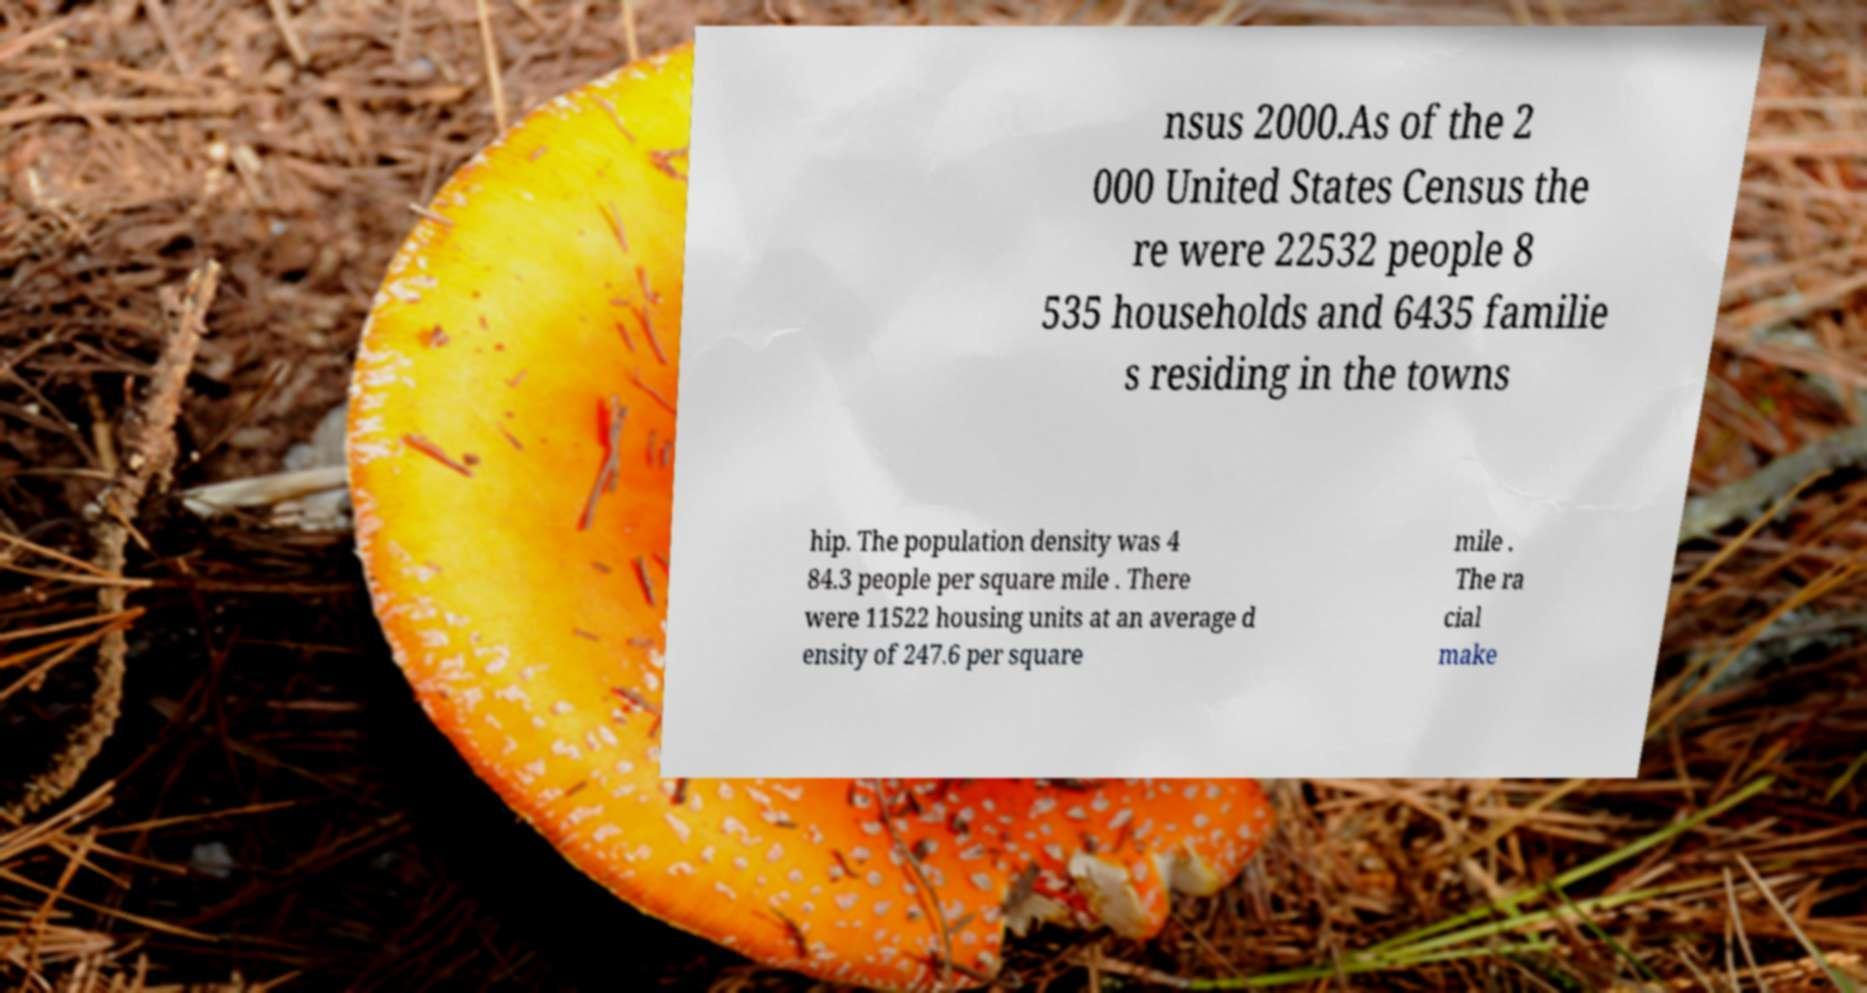Could you extract and type out the text from this image? nsus 2000.As of the 2 000 United States Census the re were 22532 people 8 535 households and 6435 familie s residing in the towns hip. The population density was 4 84.3 people per square mile . There were 11522 housing units at an average d ensity of 247.6 per square mile . The ra cial make 